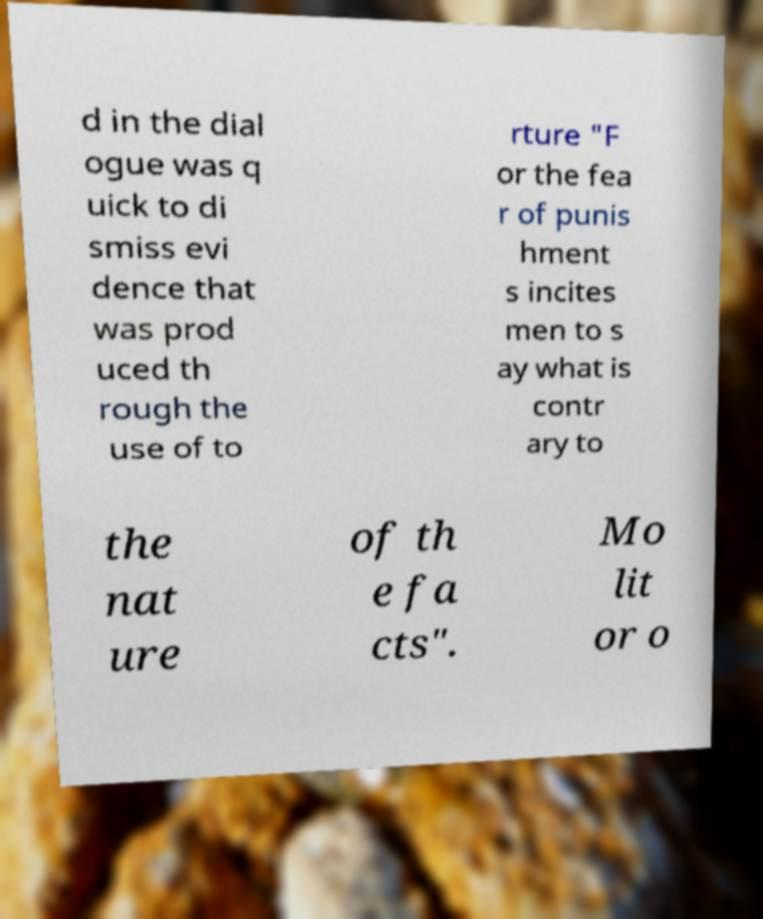Can you accurately transcribe the text from the provided image for me? d in the dial ogue was q uick to di smiss evi dence that was prod uced th rough the use of to rture "F or the fea r of punis hment s incites men to s ay what is contr ary to the nat ure of th e fa cts". Mo lit or o 